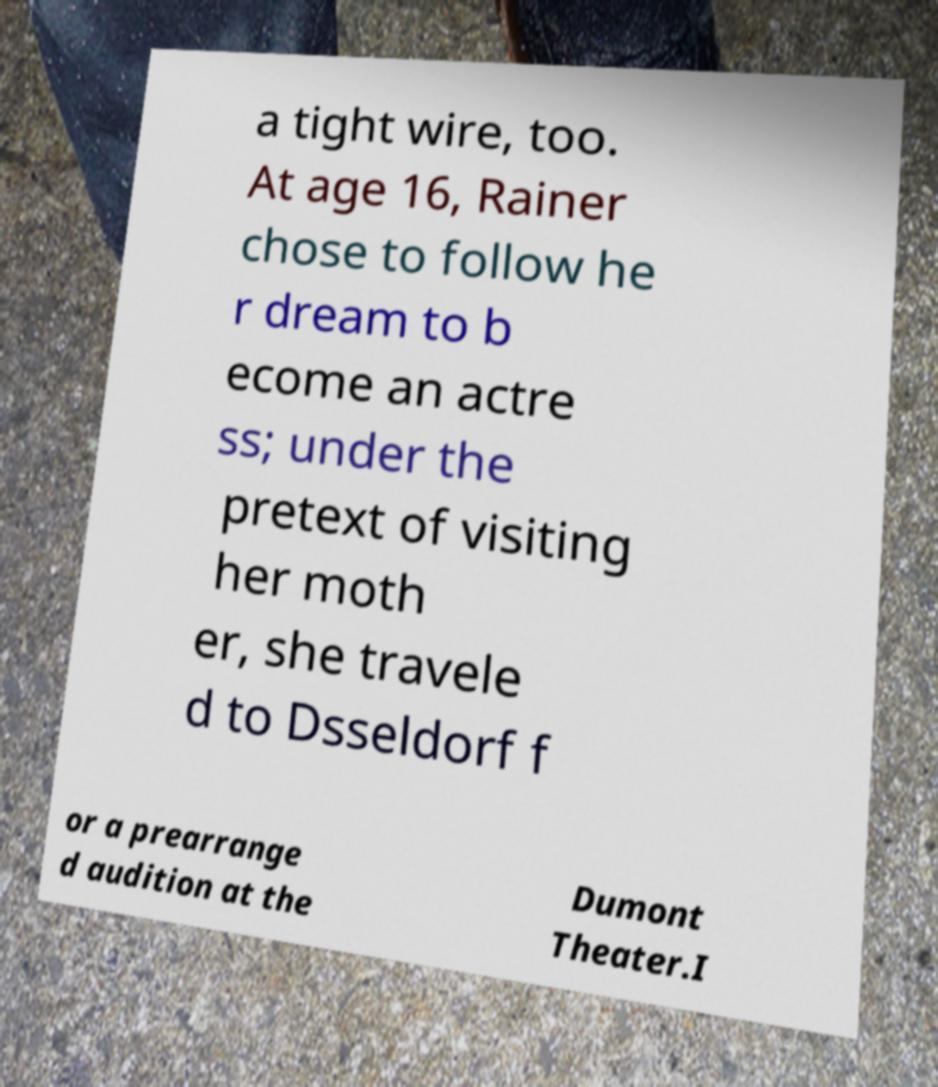Could you assist in decoding the text presented in this image and type it out clearly? a tight wire, too. At age 16, Rainer chose to follow he r dream to b ecome an actre ss; under the pretext of visiting her moth er, she travele d to Dsseldorf f or a prearrange d audition at the Dumont Theater.I 